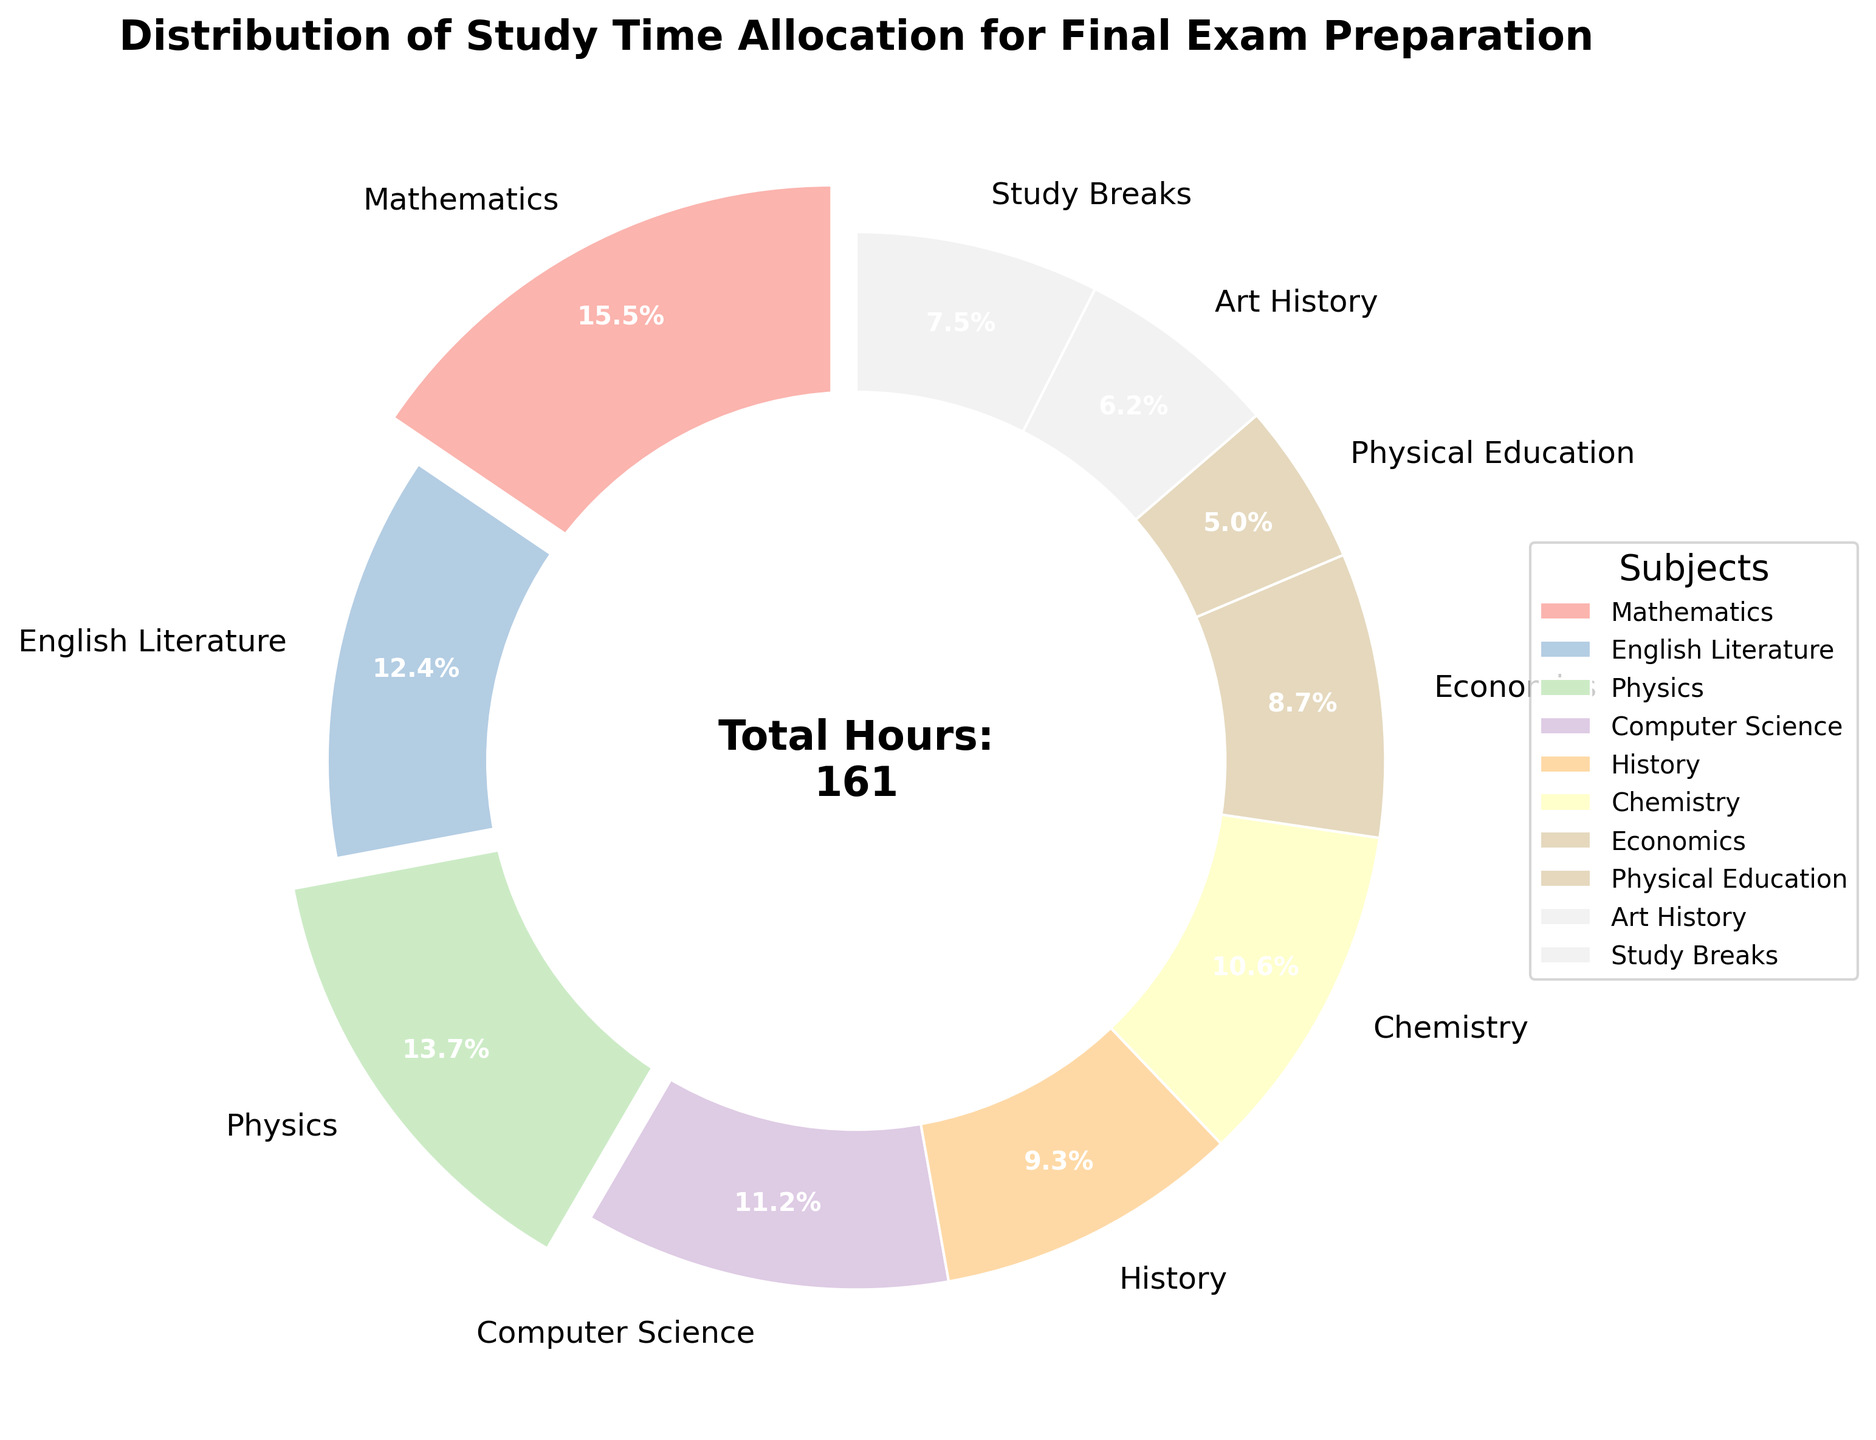What's the total number of hours allocated to Mathematics, Physics, and Chemistry combined? Add the hours for Mathematics (25), Physics (22), and Chemistry (17). 25 + 22 + 17 = 64 hours.
Answer: 64 hours Which subject has the largest time allocation for final exam preparation? The subject with the largest percentage in the pie chart is Mathematics, indicated by the slice that is exploded and holds 25 hours (25/181 * 100 ≈ 13.8%).
Answer: Mathematics Are Study Breaks allocated more or less time than Art History? Study Breaks have 12 hours and Art History has 10 hours. Since 12 > 10, Study Breaks are allocated more time than Art History.
Answer: More Which two subjects combined have an allocation closest to the number of hours for Mathematics alone? Mathematics has 25 hours. Physics (22) and Economics (14) together have 22 + 14 = 36 hours, which is far more than 25. Computer Science (18) and Economics (14) together have 18 + 14 = 32, closer but still more. Chemistry (17) and English Literature (20) together have 17 + 20 = 37, closer but still more. The closest combination without exceeding is Chemistry (17) and Computer Science (18), which together have 17 + 18 = 35, which doesn't match but is close in concept.
Answer: None exactly, closest non-exceeding combination is Chemistry and Computer Science What is the percentage of total study time allocated to subjects other than Mathematics, English Literature, and Physics? First, sum the hours for all subjects except Mathematics (25), English Literature (20), and Physics (22). Total study hours = 181, remaining subjects' hours = 181 - (25 + 20 + 22) = 114. The percentage is (114 / 181 * 100) ≈ 63%.
Answer: 63% How does the allocation to Physical Education compare to the allocation for Art History? Physical Education is allotted 8 hours, and Art History is allotted 10 hours. Since 8 < 10, Physical Education has fewer hours than Art History.
Answer: Less What is the difference in study time allocation between the subject with the highest hours and the subject with the lowest hours? The highest allocation is to Mathematics with 25 hours and the lowest is to Physical Education with 8 hours. The difference is 25 - 8 = 17 hours.
Answer: 17 hours 